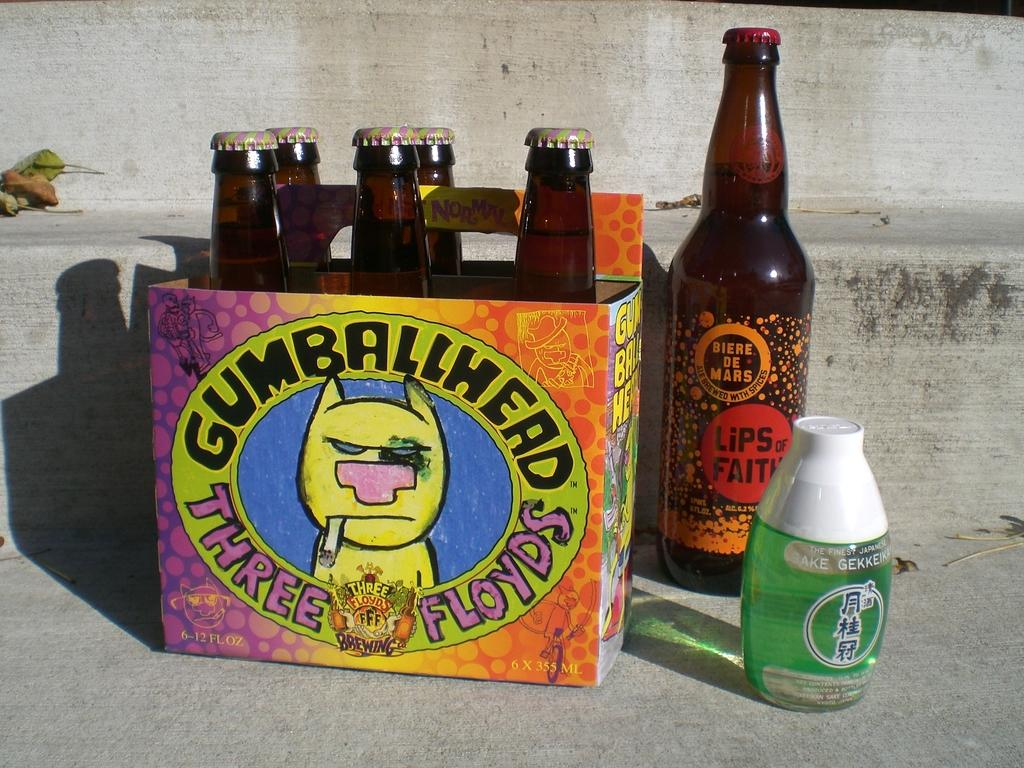<image>
Offer a succinct explanation of the picture presented. A box of bottles on pavement has an image of a smoking animal with the words GUMBALLHEAD THREE FLOYDS around it. 